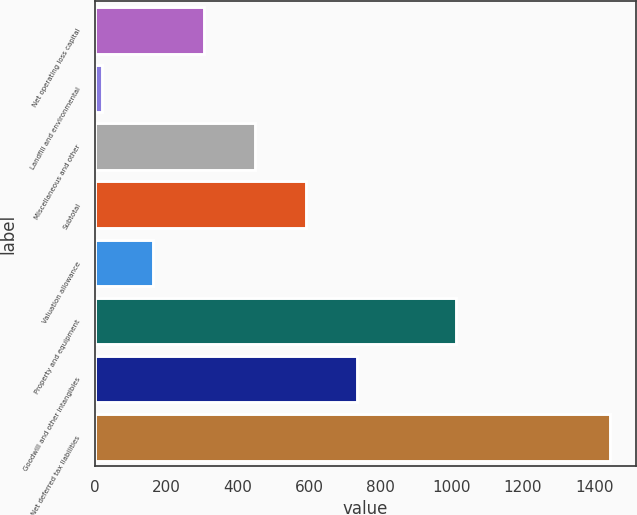Convert chart. <chart><loc_0><loc_0><loc_500><loc_500><bar_chart><fcel>Net operating loss capital<fcel>Landfill and environmental<fcel>Miscellaneous and other<fcel>Subtotal<fcel>Valuation allowance<fcel>Property and equipment<fcel>Goodwill and other intangibles<fcel>Net deferred tax liabilities<nl><fcel>305.8<fcel>21<fcel>448.2<fcel>590.6<fcel>163.4<fcel>1012<fcel>736<fcel>1445<nl></chart> 